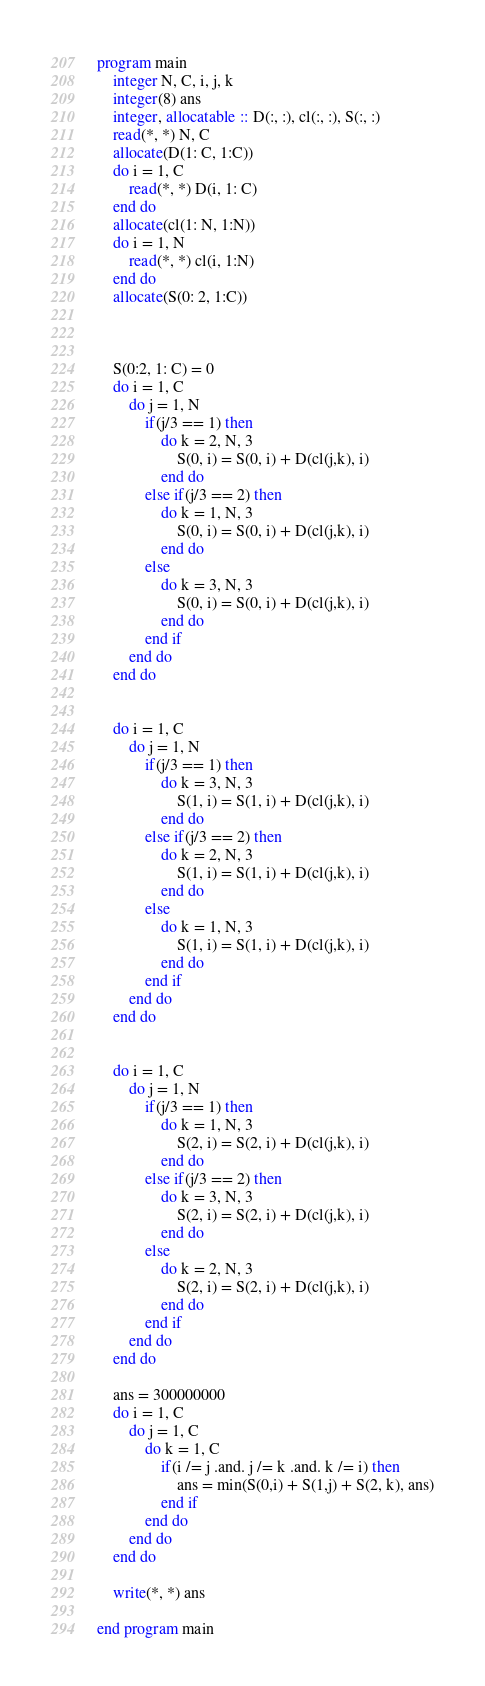<code> <loc_0><loc_0><loc_500><loc_500><_FORTRAN_>program main
	integer N, C, i, j, k
	integer(8) ans
	integer, allocatable :: D(:, :), cl(:, :), S(:, :)
	read(*, *) N, C
	allocate(D(1: C, 1:C))
	do i = 1, C
		read(*, *) D(i, 1: C)
	end do
	allocate(cl(1: N, 1:N))
	do i = 1, N
		read(*, *) cl(i, 1:N)
	end do
	allocate(S(0: 2, 1:C))

	
	
	S(0:2, 1: C) = 0
	do i = 1, C
		do j = 1, N
			if(j/3 == 1) then
				do k = 2, N, 3
					S(0, i) = S(0, i) + D(cl(j,k), i)
				end do
			else if(j/3 == 2) then
				do k = 1, N, 3
					S(0, i) = S(0, i) + D(cl(j,k), i)
				end do
			else 
				do k = 3, N, 3
					S(0, i) = S(0, i) + D(cl(j,k), i)
				end do
			end if
		end do
	end do
	

	do i = 1, C
		do j = 1, N
			if(j/3 == 1) then
				do k = 3, N, 3
					S(1, i) = S(1, i) + D(cl(j,k), i)
				end do
			else if(j/3 == 2) then
				do k = 2, N, 3
					S(1, i) = S(1, i) + D(cl(j,k), i)
				end do
			else 
				do k = 1, N, 3
					S(1, i) = S(1, i) + D(cl(j,k), i)
				end do
			end if
		end do
	end do
	
	
	do i = 1, C
		do j = 1, N
			if(j/3 == 1) then
				do k = 1, N, 3
					S(2, i) = S(2, i) + D(cl(j,k), i)
				end do
			else if(j/3 == 2) then
				do k = 3, N, 3
					S(2, i) = S(2, i) + D(cl(j,k), i)
				end do
			else 
				do k = 2, N, 3
					S(2, i) = S(2, i) + D(cl(j,k), i)
				end do
			end if
		end do
	end do
	
	ans = 300000000
	do i = 1, C
		do j = 1, C
			do k = 1, C
				if(i /= j .and. j /= k .and. k /= i) then
					ans = min(S(0,i) + S(1,j) + S(2, k), ans)
				end if
			end do
		end do
	end do

	write(*, *) ans
	
end program main</code> 